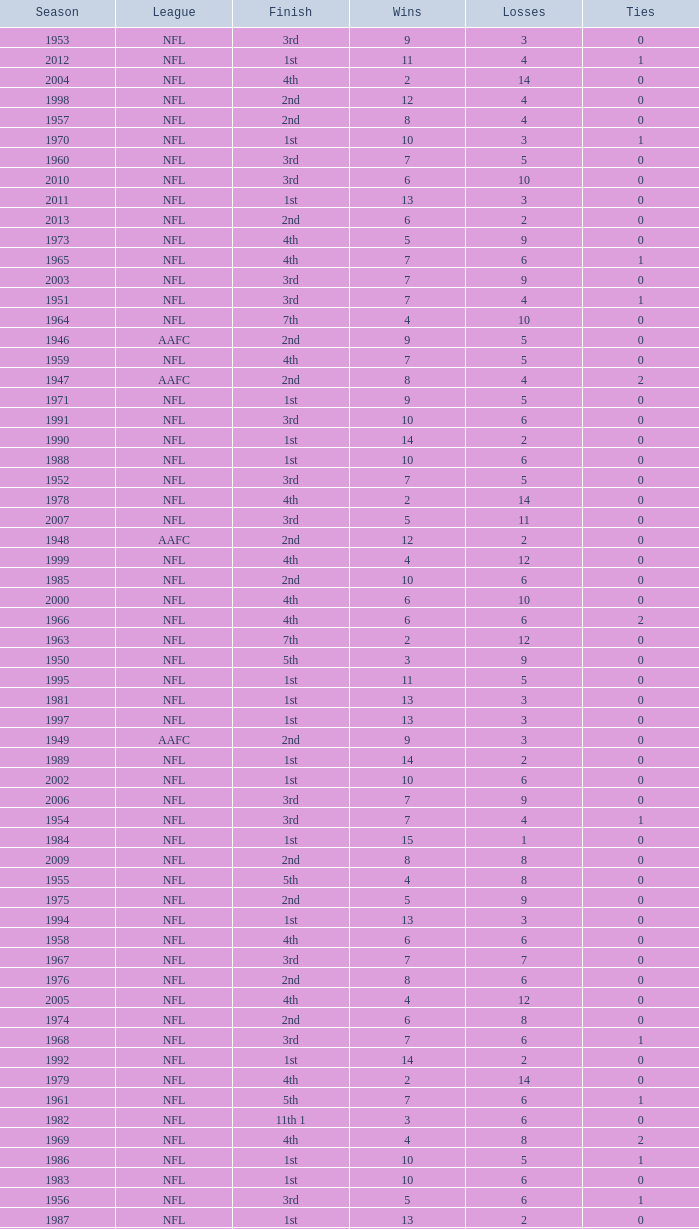What league had a finish of 2nd and 3 losses? AAFC. Help me parse the entirety of this table. {'header': ['Season', 'League', 'Finish', 'Wins', 'Losses', 'Ties'], 'rows': [['1953', 'NFL', '3rd', '9', '3', '0'], ['2012', 'NFL', '1st', '11', '4', '1'], ['2004', 'NFL', '4th', '2', '14', '0'], ['1998', 'NFL', '2nd', '12', '4', '0'], ['1957', 'NFL', '2nd', '8', '4', '0'], ['1970', 'NFL', '1st', '10', '3', '1'], ['1960', 'NFL', '3rd', '7', '5', '0'], ['2010', 'NFL', '3rd', '6', '10', '0'], ['2011', 'NFL', '1st', '13', '3', '0'], ['2013', 'NFL', '2nd', '6', '2', '0'], ['1973', 'NFL', '4th', '5', '9', '0'], ['1965', 'NFL', '4th', '7', '6', '1'], ['2003', 'NFL', '3rd', '7', '9', '0'], ['1951', 'NFL', '3rd', '7', '4', '1'], ['1964', 'NFL', '7th', '4', '10', '0'], ['1946', 'AAFC', '2nd', '9', '5', '0'], ['1959', 'NFL', '4th', '7', '5', '0'], ['1947', 'AAFC', '2nd', '8', '4', '2'], ['1971', 'NFL', '1st', '9', '5', '0'], ['1991', 'NFL', '3rd', '10', '6', '0'], ['1990', 'NFL', '1st', '14', '2', '0'], ['1988', 'NFL', '1st', '10', '6', '0'], ['1952', 'NFL', '3rd', '7', '5', '0'], ['1978', 'NFL', '4th', '2', '14', '0'], ['2007', 'NFL', '3rd', '5', '11', '0'], ['1948', 'AAFC', '2nd', '12', '2', '0'], ['1999', 'NFL', '4th', '4', '12', '0'], ['1985', 'NFL', '2nd', '10', '6', '0'], ['2000', 'NFL', '4th', '6', '10', '0'], ['1966', 'NFL', '4th', '6', '6', '2'], ['1963', 'NFL', '7th', '2', '12', '0'], ['1950', 'NFL', '5th', '3', '9', '0'], ['1995', 'NFL', '1st', '11', '5', '0'], ['1981', 'NFL', '1st', '13', '3', '0'], ['1997', 'NFL', '1st', '13', '3', '0'], ['1949', 'AAFC', '2nd', '9', '3', '0'], ['1989', 'NFL', '1st', '14', '2', '0'], ['2002', 'NFL', '1st', '10', '6', '0'], ['2006', 'NFL', '3rd', '7', '9', '0'], ['1954', 'NFL', '3rd', '7', '4', '1'], ['1984', 'NFL', '1st', '15', '1', '0'], ['2009', 'NFL', '2nd', '8', '8', '0'], ['1955', 'NFL', '5th', '4', '8', '0'], ['1975', 'NFL', '2nd', '5', '9', '0'], ['1994', 'NFL', '1st', '13', '3', '0'], ['1958', 'NFL', '4th', '6', '6', '0'], ['1967', 'NFL', '3rd', '7', '7', '0'], ['1976', 'NFL', '2nd', '8', '6', '0'], ['2005', 'NFL', '4th', '4', '12', '0'], ['1974', 'NFL', '2nd', '6', '8', '0'], ['1968', 'NFL', '3rd', '7', '6', '1'], ['1992', 'NFL', '1st', '14', '2', '0'], ['1979', 'NFL', '4th', '2', '14', '0'], ['1961', 'NFL', '5th', '7', '6', '1'], ['1982', 'NFL', '11th 1', '3', '6', '0'], ['1969', 'NFL', '4th', '4', '8', '2'], ['1986', 'NFL', '1st', '10', '5', '1'], ['1983', 'NFL', '1st', '10', '6', '0'], ['1956', 'NFL', '3rd', '5', '6', '1'], ['1987', 'NFL', '1st', '13', '2', '0'], ['1977', 'NFL', '3rd', '5', '9', '0'], ['1993', 'NFL', '1st', '10', '6', '0'], ['2001', 'NFL', '2nd', '12', '4', '0'], ['1962', 'NFL', '5th', '6', '8', '0'], ['1980', 'NFL', '3rd', '6', '10', '0'], ['1996', 'NFL', '2nd', '12', '4', '0'], ['2008', 'NFL', '2nd', '7', '9', '0'], ['1972', 'NFL', '1st', '8', '5', '1']]} 